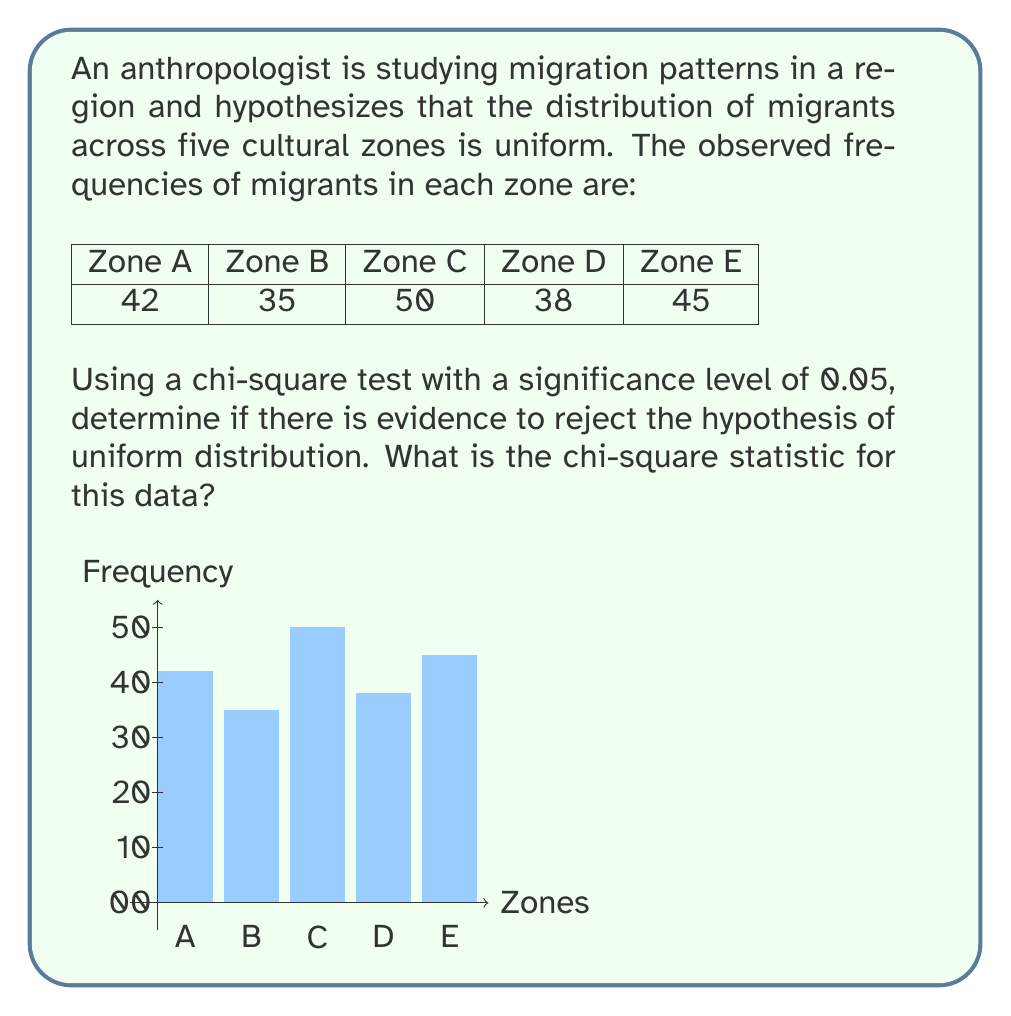Could you help me with this problem? To analyze this data using a chi-square test, we'll follow these steps:

1) Calculate the total number of observations:
   $N = 42 + 35 + 50 + 38 + 45 = 210$

2) Calculate the expected frequency for each zone assuming uniform distribution:
   $E = N / 5 = 210 / 5 = 42$

3) Calculate the chi-square statistic using the formula:
   $$\chi^2 = \sum_{i=1}^{5} \frac{(O_i - E_i)^2}{E_i}$$
   where $O_i$ is the observed frequency and $E_i$ is the expected frequency.

4) Compute each term:
   Zone A: $\frac{(42 - 42)^2}{42} = 0$
   Zone B: $\frac{(35 - 42)^2}{42} = 1.1667$
   Zone C: $\frac{(50 - 42)^2}{42} = 1.5238$
   Zone D: $\frac{(38 - 42)^2}{42} = 0.3810$
   Zone E: $\frac{(45 - 42)^2}{42} = 0.2143$

5) Sum all terms:
   $\chi^2 = 0 + 1.1667 + 1.5238 + 0.3810 + 0.2143 = 3.2858$

6) The degrees of freedom (df) for this test is:
   $df = \text{number of categories} - 1 = 5 - 1 = 4$

7) The critical value for $\chi^2$ with df = 4 and α = 0.05 is 9.488.

Since the calculated $\chi^2$ (3.2858) is less than the critical value (9.488), we fail to reject the null hypothesis. This suggests that there isn't sufficient evidence to conclude that the distribution of migrants across the five cultural zones is non-uniform.
Answer: $\chi^2 = 3.2858$ 